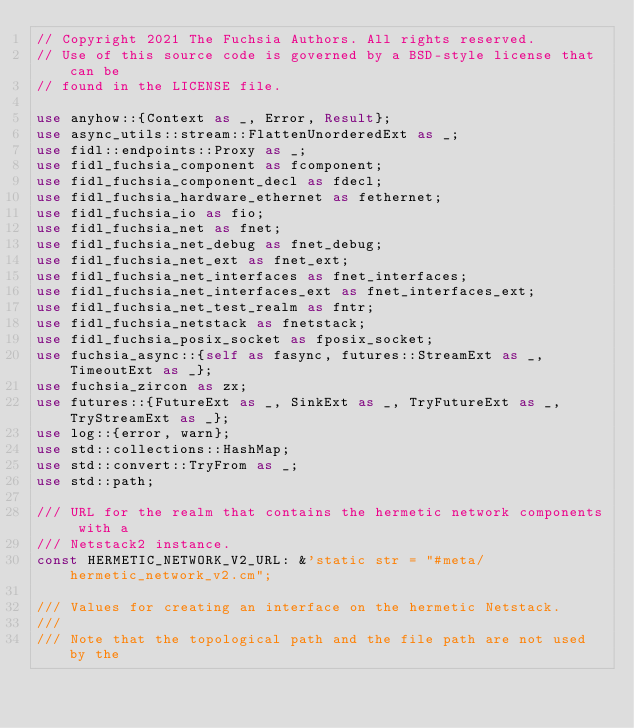<code> <loc_0><loc_0><loc_500><loc_500><_Rust_>// Copyright 2021 The Fuchsia Authors. All rights reserved.
// Use of this source code is governed by a BSD-style license that can be
// found in the LICENSE file.

use anyhow::{Context as _, Error, Result};
use async_utils::stream::FlattenUnorderedExt as _;
use fidl::endpoints::Proxy as _;
use fidl_fuchsia_component as fcomponent;
use fidl_fuchsia_component_decl as fdecl;
use fidl_fuchsia_hardware_ethernet as fethernet;
use fidl_fuchsia_io as fio;
use fidl_fuchsia_net as fnet;
use fidl_fuchsia_net_debug as fnet_debug;
use fidl_fuchsia_net_ext as fnet_ext;
use fidl_fuchsia_net_interfaces as fnet_interfaces;
use fidl_fuchsia_net_interfaces_ext as fnet_interfaces_ext;
use fidl_fuchsia_net_test_realm as fntr;
use fidl_fuchsia_netstack as fnetstack;
use fidl_fuchsia_posix_socket as fposix_socket;
use fuchsia_async::{self as fasync, futures::StreamExt as _, TimeoutExt as _};
use fuchsia_zircon as zx;
use futures::{FutureExt as _, SinkExt as _, TryFutureExt as _, TryStreamExt as _};
use log::{error, warn};
use std::collections::HashMap;
use std::convert::TryFrom as _;
use std::path;

/// URL for the realm that contains the hermetic network components with a
/// Netstack2 instance.
const HERMETIC_NETWORK_V2_URL: &'static str = "#meta/hermetic_network_v2.cm";

/// Values for creating an interface on the hermetic Netstack.
///
/// Note that the topological path and the file path are not used by the</code> 